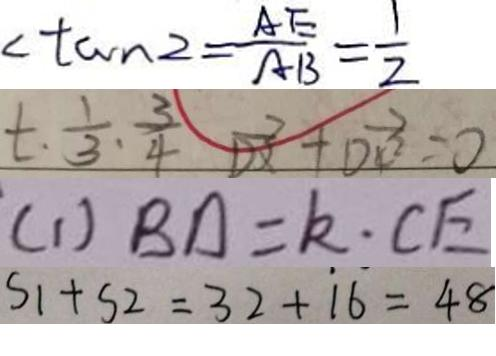Convert formula to latex. <formula><loc_0><loc_0><loc_500><loc_500>< \tan 2 = \frac { A E } { A B } = \frac { 1 } { 2 } 
 t . \frac { 1 } { 3 } . \frac { 3 } { 4 } \overrightarrow { D x } + \overrightarrow { D 4 ^ { 2 } } = 0 
 ( 1 ) B D = k \cdot C E 
 S _ { 1 } + s 2 = 3 2 + 1 6 = 4 8</formula> 